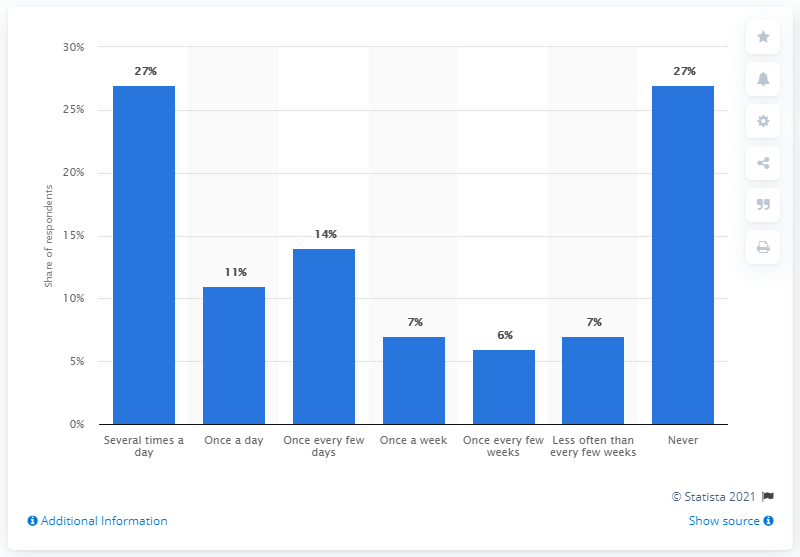Indicate a few pertinent items in this graphic. 14% of respondents reported using Facebook Messenger every few days or more often. The percentage of respondents who use Facebook Messenger several times a day is not significantly different from the percentage of respondents who have never used it. 